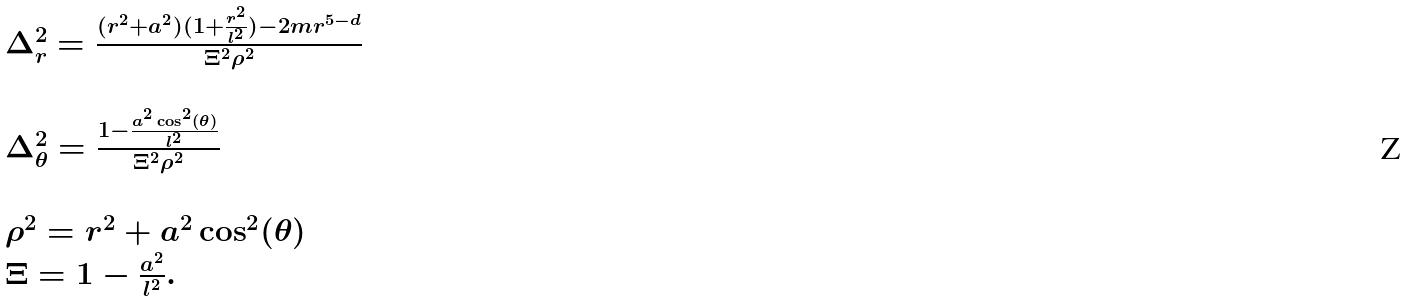<formula> <loc_0><loc_0><loc_500><loc_500>\begin{array} { l } \Delta _ { r } ^ { 2 } = \frac { ( r ^ { 2 } + a ^ { 2 } ) ( 1 + \frac { r ^ { 2 } } { l ^ { 2 } } ) - 2 m r ^ { 5 - d } } { \Xi ^ { 2 } \rho ^ { 2 } } \\ \\ \Delta _ { \theta } ^ { 2 } = \frac { 1 - \frac { a ^ { 2 } \cos ^ { 2 } ( \theta ) } { l ^ { 2 } } } { \Xi ^ { 2 } \rho ^ { 2 } } \\ \\ \rho ^ { 2 } = r ^ { 2 } + a ^ { 2 } \cos ^ { 2 } ( \theta ) \\ \Xi = 1 - \frac { a ^ { 2 } } { l ^ { 2 } } . \end{array}</formula> 